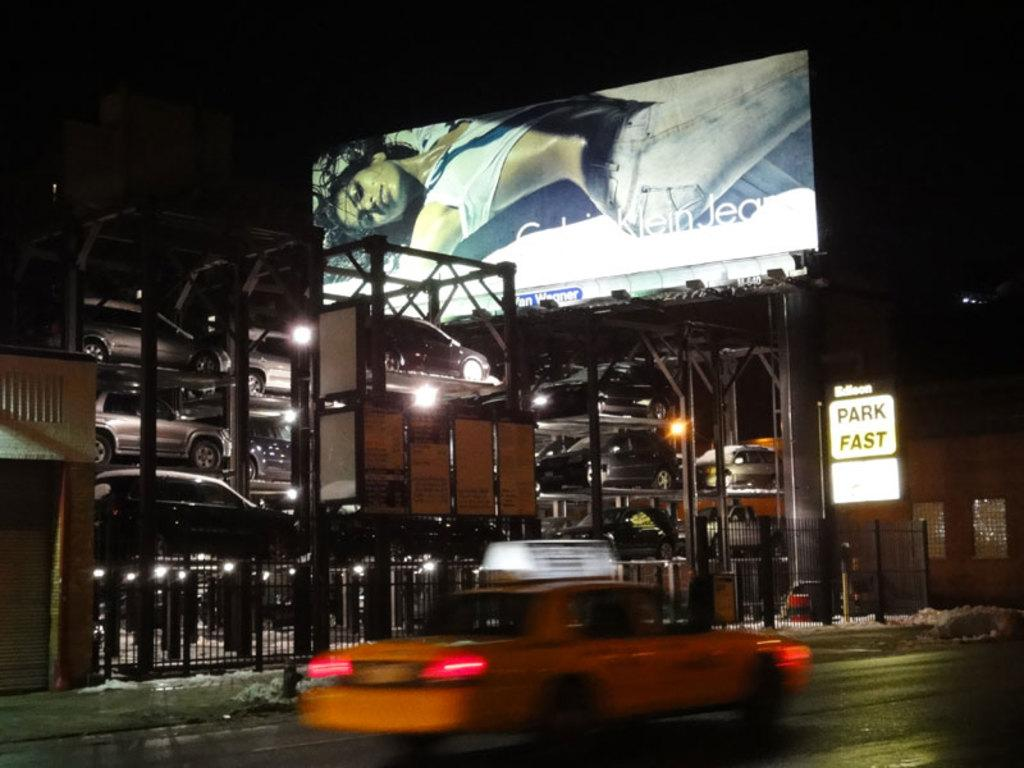<image>
Summarize the visual content of the image. A taxi cab is driving past at Park Fast sign. 